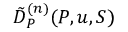Convert formula to latex. <formula><loc_0><loc_0><loc_500><loc_500>\tilde { D } _ { P } ^ { ( n ) } ( P , u , S )</formula> 